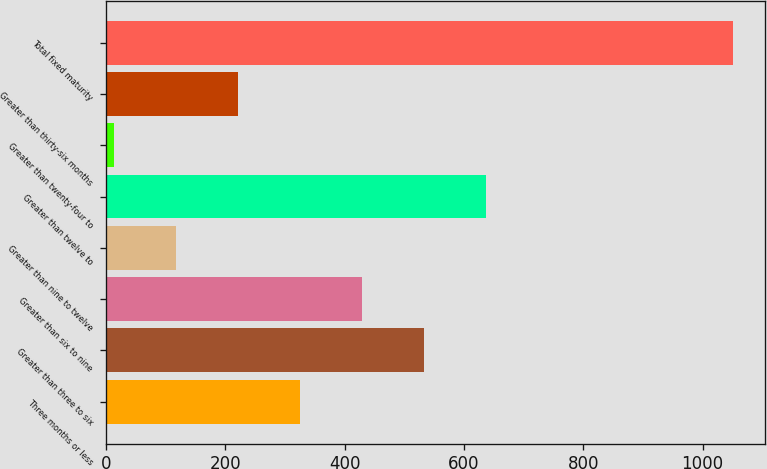Convert chart to OTSL. <chart><loc_0><loc_0><loc_500><loc_500><bar_chart><fcel>Three months or less<fcel>Greater than three to six<fcel>Greater than six to nine<fcel>Greater than nine to twelve<fcel>Greater than twelve to<fcel>Greater than twenty-four to<fcel>Greater than thirty-six months<fcel>Total fixed maturity<nl><fcel>324.7<fcel>532.3<fcel>428.5<fcel>117.1<fcel>636.1<fcel>13.3<fcel>220.9<fcel>1051.3<nl></chart> 